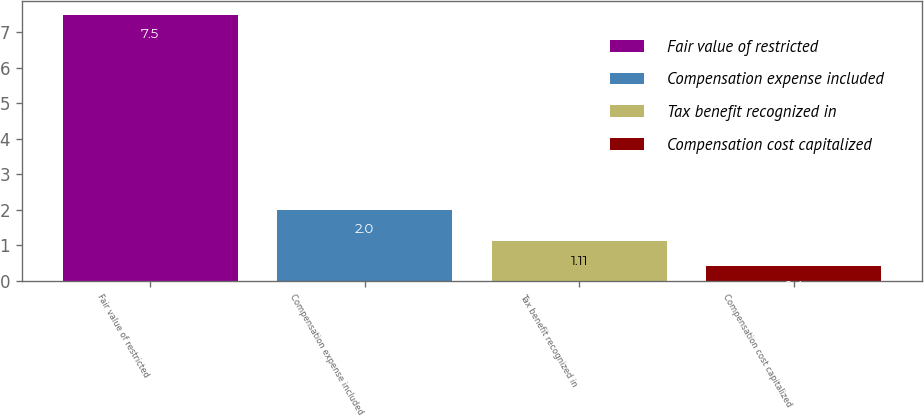Convert chart. <chart><loc_0><loc_0><loc_500><loc_500><bar_chart><fcel>Fair value of restricted<fcel>Compensation expense included<fcel>Tax benefit recognized in<fcel>Compensation cost capitalized<nl><fcel>7.5<fcel>2<fcel>1.11<fcel>0.4<nl></chart> 